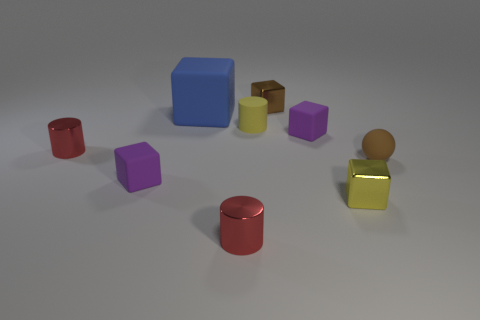Subtract 2 blocks. How many blocks are left? 3 Subtract all blue blocks. How many blocks are left? 4 Subtract all yellow blocks. How many blocks are left? 4 Subtract all red cubes. Subtract all gray cylinders. How many cubes are left? 5 Subtract all balls. How many objects are left? 8 Subtract all tiny yellow cylinders. Subtract all big matte cubes. How many objects are left? 7 Add 3 blue things. How many blue things are left? 4 Add 6 tiny shiny cylinders. How many tiny shiny cylinders exist? 8 Subtract 1 blue cubes. How many objects are left? 8 